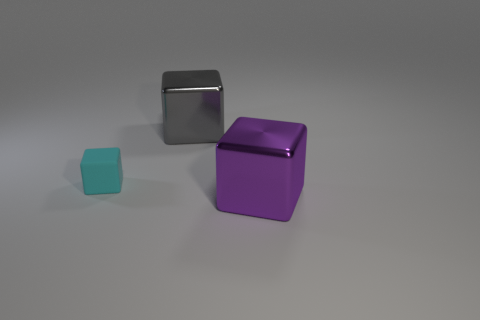Add 2 purple objects. How many objects exist? 5 Subtract 0 brown cubes. How many objects are left? 3 Subtract all tiny cubes. Subtract all cyan rubber things. How many objects are left? 1 Add 3 tiny cyan cubes. How many tiny cyan cubes are left? 4 Add 1 large blocks. How many large blocks exist? 3 